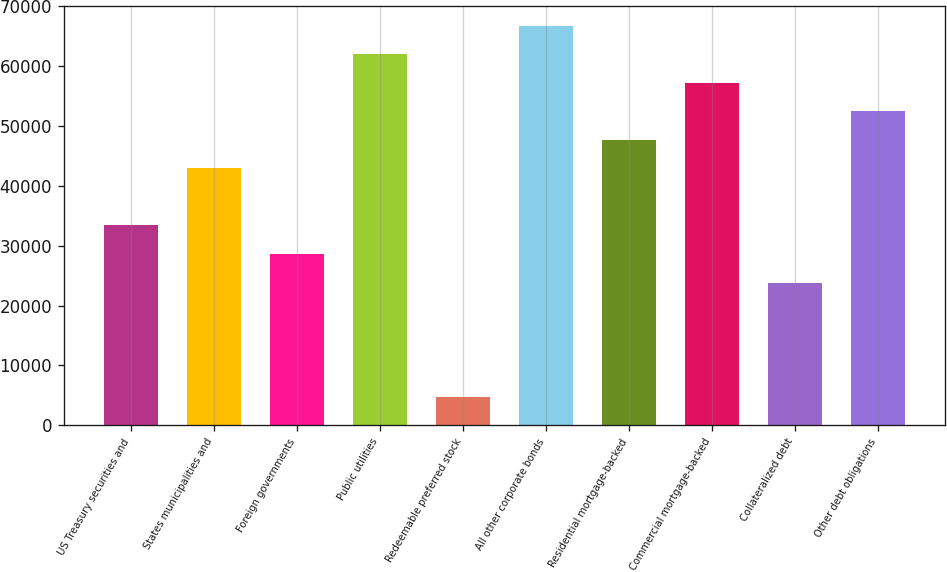Convert chart to OTSL. <chart><loc_0><loc_0><loc_500><loc_500><bar_chart><fcel>US Treasury securities and<fcel>States municipalities and<fcel>Foreign governments<fcel>Public utilities<fcel>Redeemable preferred stock<fcel>All other corporate bonds<fcel>Residential mortgage-backed<fcel>Commercial mortgage-backed<fcel>Collateralized debt<fcel>Other debt obligations<nl><fcel>33393.9<fcel>42931.4<fcel>28625.1<fcel>62006.5<fcel>4781.18<fcel>66775.3<fcel>47700.2<fcel>57237.8<fcel>23856.3<fcel>52469<nl></chart> 